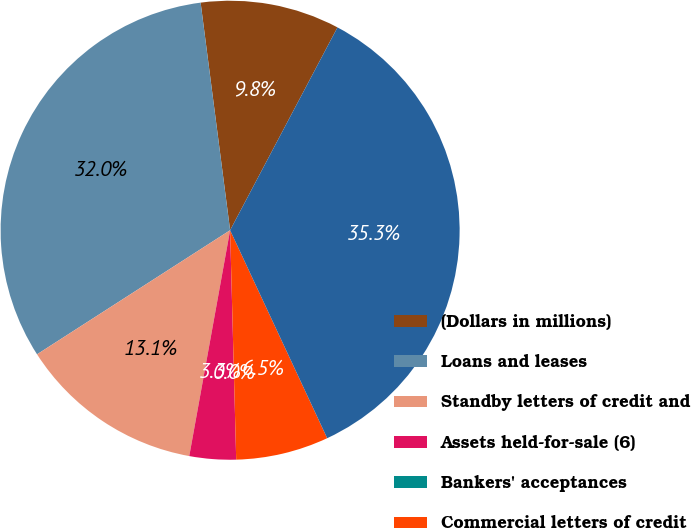Convert chart. <chart><loc_0><loc_0><loc_500><loc_500><pie_chart><fcel>(Dollars in millions)<fcel>Loans and leases<fcel>Standby letters of credit and<fcel>Assets held-for-sale (6)<fcel>Bankers' acceptances<fcel>Commercial letters of credit<fcel>Total commercial credit<nl><fcel>9.8%<fcel>32.04%<fcel>13.06%<fcel>3.27%<fcel>0.0%<fcel>6.53%<fcel>35.3%<nl></chart> 